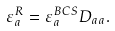<formula> <loc_0><loc_0><loc_500><loc_500>\varepsilon _ { a } ^ { R } = \varepsilon _ { a } ^ { B C S } D _ { a a } .</formula> 